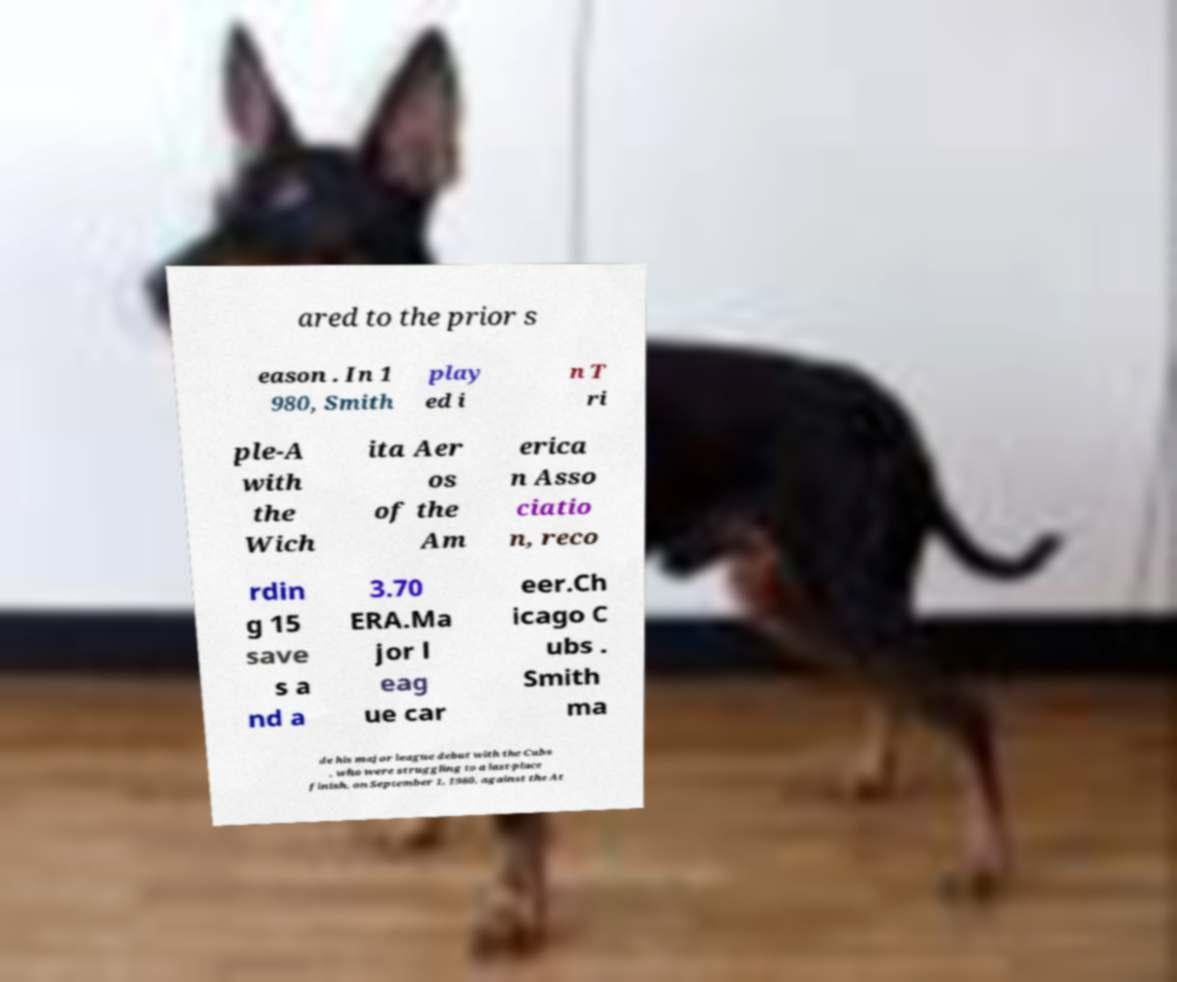Please identify and transcribe the text found in this image. ared to the prior s eason . In 1 980, Smith play ed i n T ri ple-A with the Wich ita Aer os of the Am erica n Asso ciatio n, reco rdin g 15 save s a nd a 3.70 ERA.Ma jor l eag ue car eer.Ch icago C ubs . Smith ma de his major league debut with the Cubs , who were struggling to a last-place finish, on September 1, 1980, against the At 